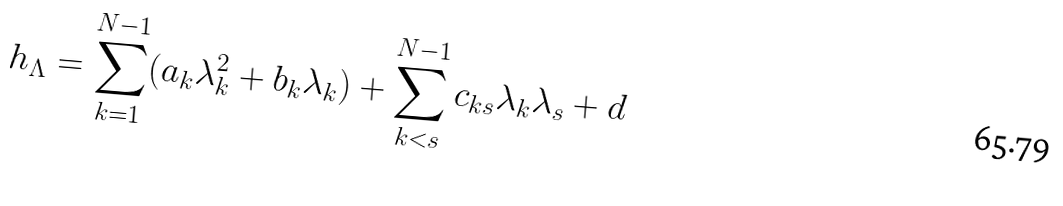Convert formula to latex. <formula><loc_0><loc_0><loc_500><loc_500>h _ { \Lambda } = \sum _ { k = 1 } ^ { N - 1 } ( a _ { k } \lambda _ { k } ^ { 2 } + b _ { k } \lambda _ { k } ) + \sum _ { k < s } ^ { N - 1 } c _ { k s } \lambda _ { k } \lambda _ { s } + d</formula> 